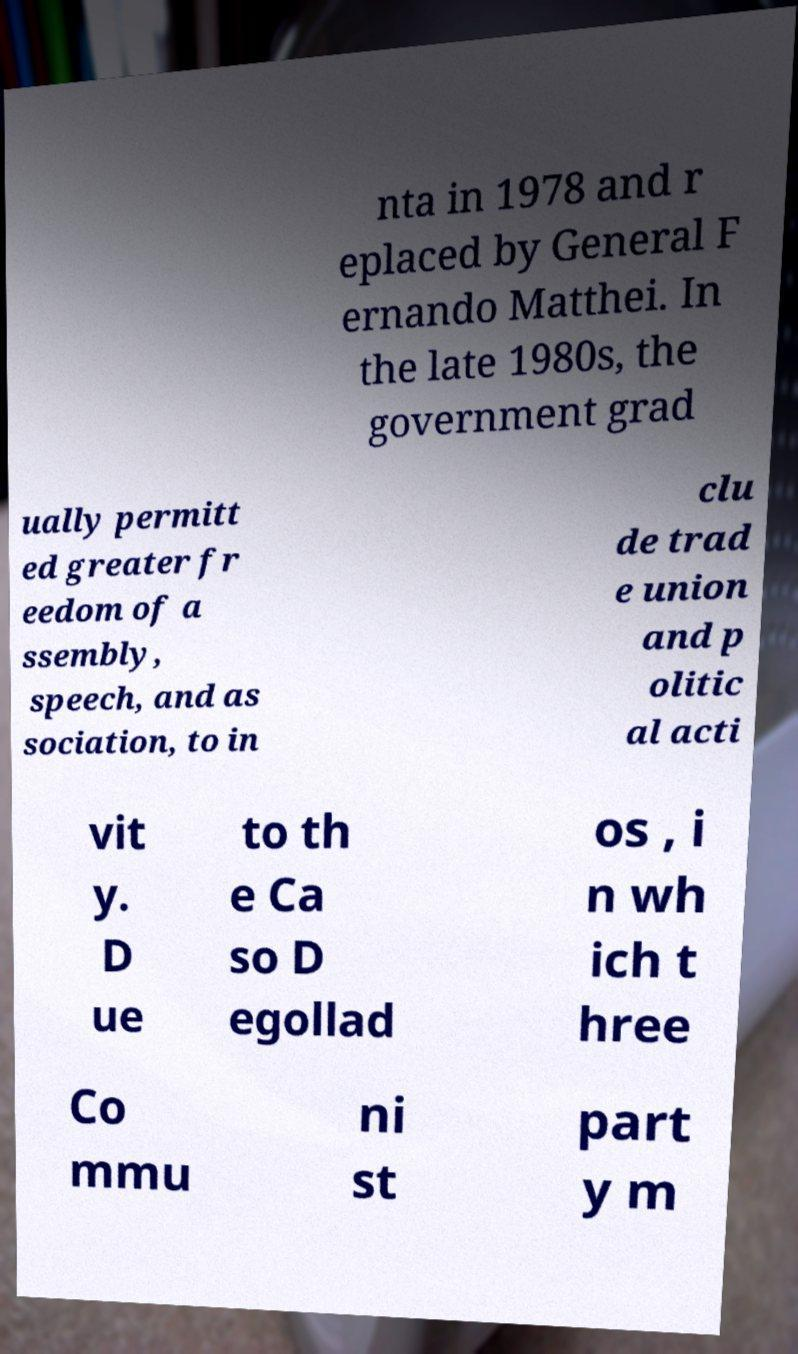Could you extract and type out the text from this image? nta in 1978 and r eplaced by General F ernando Matthei. In the late 1980s, the government grad ually permitt ed greater fr eedom of a ssembly, speech, and as sociation, to in clu de trad e union and p olitic al acti vit y. D ue to th e Ca so D egollad os , i n wh ich t hree Co mmu ni st part y m 